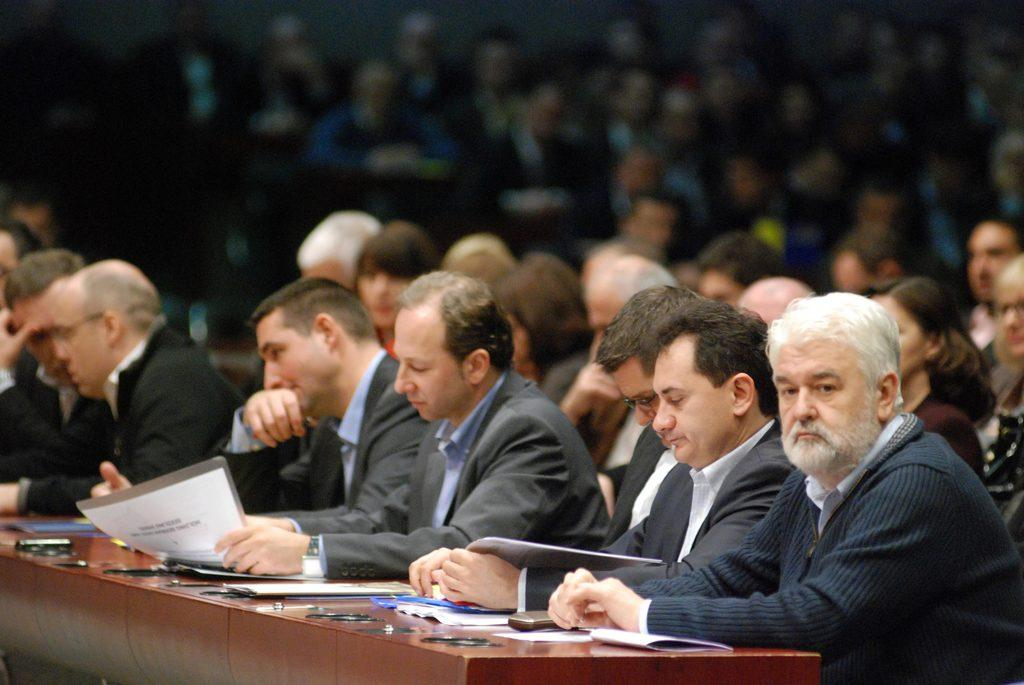What is the main object in the image? There is a table in the image. What is on the table? Papers are present on the table. What can be seen in the background of the image? In the background, people are sitting on chairs. How is the background of the image depicted? The background is blurred. How many rabbits can be seen hopping on the bed in the image? There are no rabbits or beds present in the image. What type of tramp is visible in the background of the image? There is no tramp present in the image; the background features people sitting on chairs. 